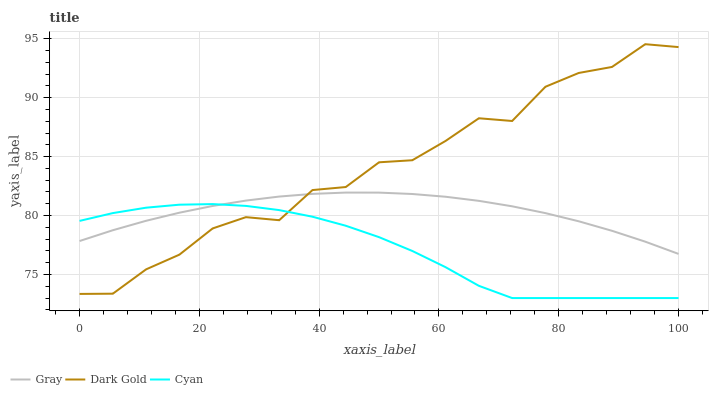Does Cyan have the minimum area under the curve?
Answer yes or no. Yes. Does Dark Gold have the maximum area under the curve?
Answer yes or no. Yes. Does Dark Gold have the minimum area under the curve?
Answer yes or no. No. Does Cyan have the maximum area under the curve?
Answer yes or no. No. Is Gray the smoothest?
Answer yes or no. Yes. Is Dark Gold the roughest?
Answer yes or no. Yes. Is Cyan the smoothest?
Answer yes or no. No. Is Cyan the roughest?
Answer yes or no. No. Does Cyan have the lowest value?
Answer yes or no. Yes. Does Dark Gold have the lowest value?
Answer yes or no. No. Does Dark Gold have the highest value?
Answer yes or no. Yes. Does Cyan have the highest value?
Answer yes or no. No. Does Cyan intersect Gray?
Answer yes or no. Yes. Is Cyan less than Gray?
Answer yes or no. No. Is Cyan greater than Gray?
Answer yes or no. No. 